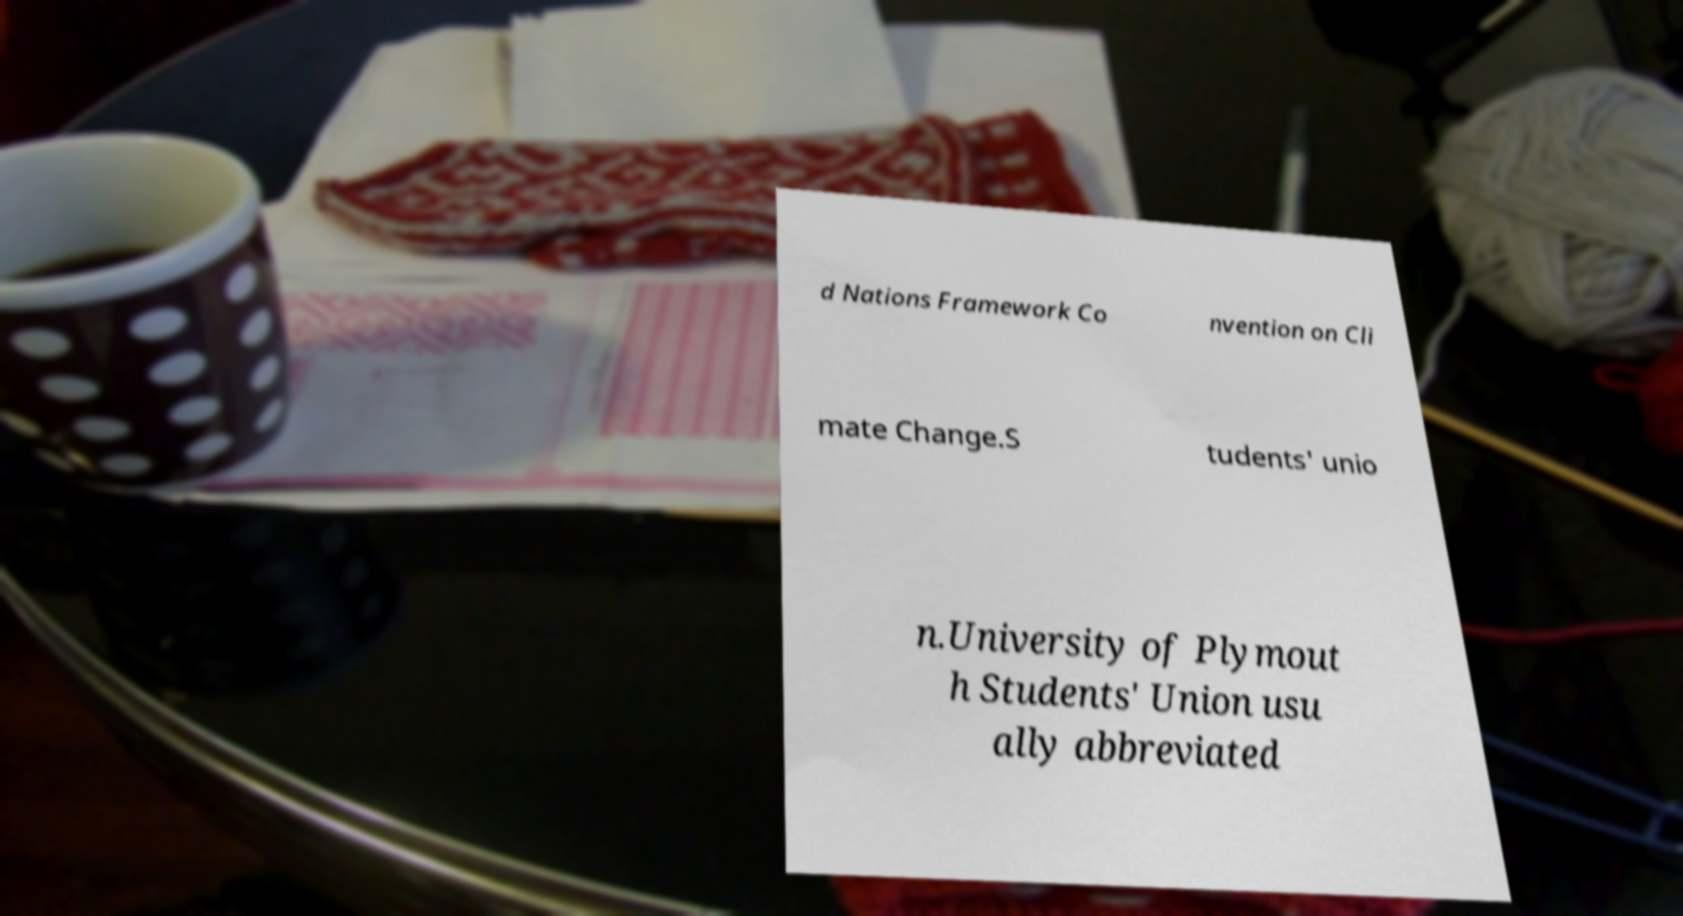What messages or text are displayed in this image? I need them in a readable, typed format. d Nations Framework Co nvention on Cli mate Change.S tudents' unio n.University of Plymout h Students' Union usu ally abbreviated 